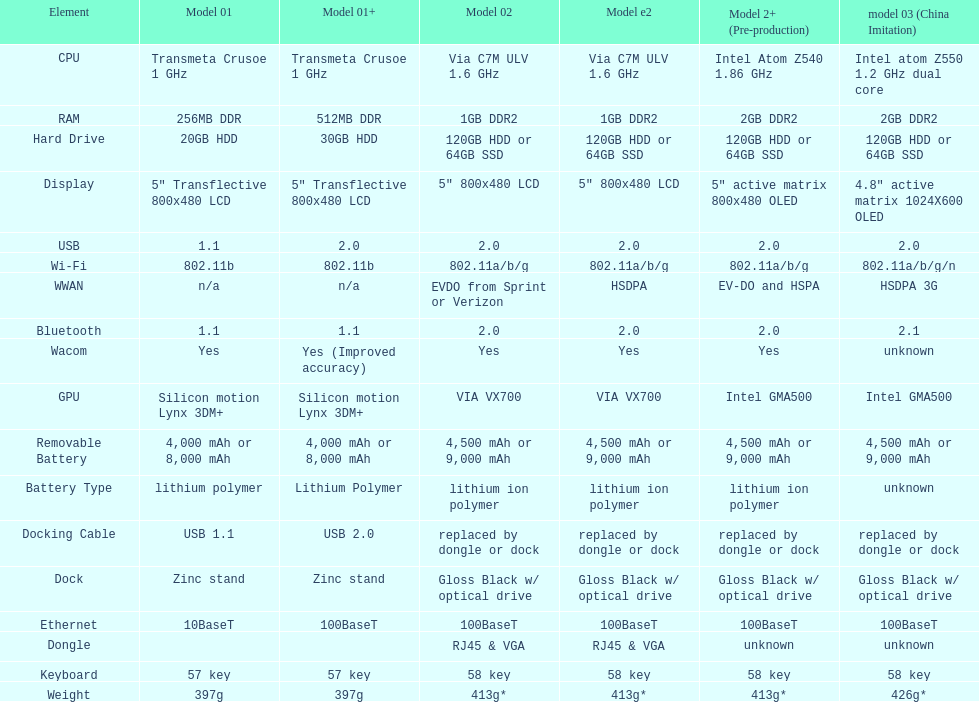How many models possess 2. 